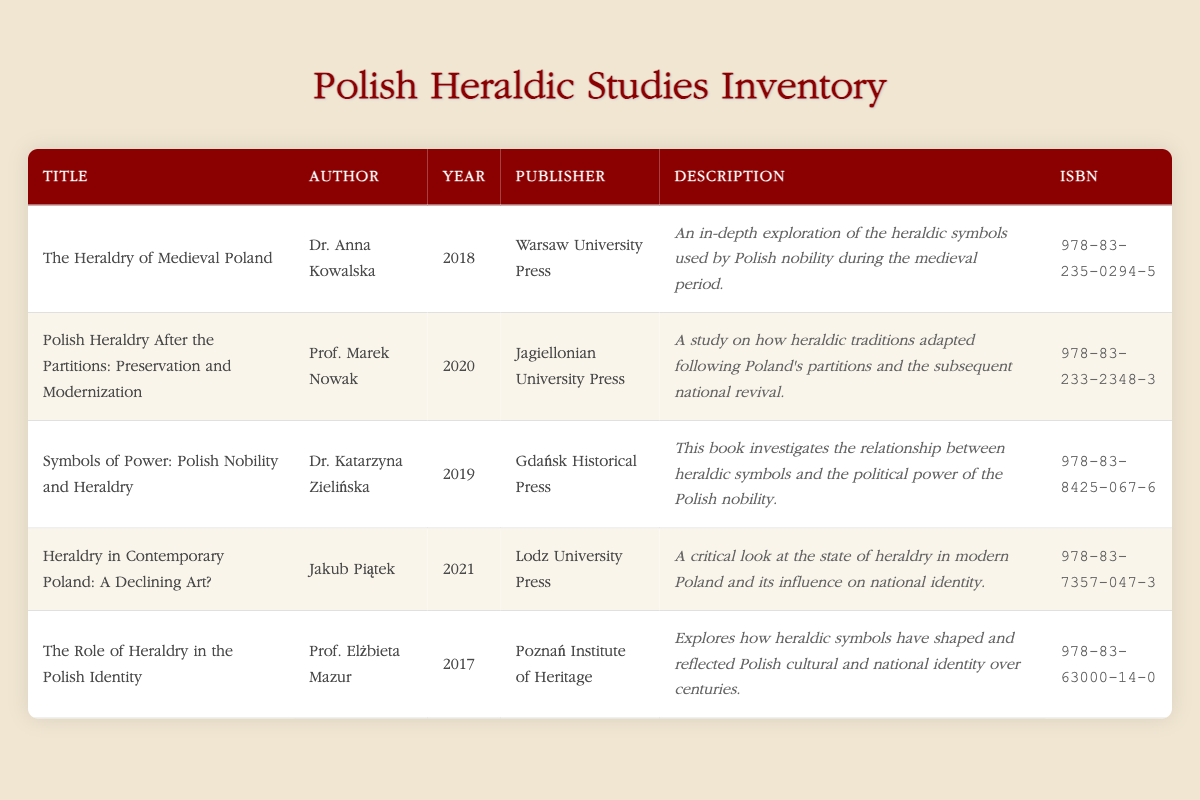What is the title of the book authored by Dr. Anna Kowalska? The table lists the publications and their authors. By scanning through the entries, "The Heraldry of Medieval Poland" corresponds to Dr. Anna Kowalska, who is identified as its author.
Answer: The Heraldry of Medieval Poland How many studies were published after the year 2018? Observing the "Year" column, the publications from 2019, 2020, and 2021 total three: "Symbols of Power: Polish Nobility and Heraldry," "Polish Heraldry After the Partitions: Preservation and Modernization," and "Heraldry in Contemporary Poland: A Declining Art?"
Answer: 3 Which publication focuses on the preservation of heraldic traditions after the partitions? The description of the publication written by Prof. Marek Nowak, titled "Polish Heraldry After the Partitions: Preservation and Modernization," directly indicates that it addresses the preservation of heraldic traditions after Poland's partitions.
Answer: Polish Heraldry After the Partitions: Preservation and Modernization Is "The Role of Heraldry in the Polish Identity" published by a professor? The table provides the author's title next to the name. In this case, Prof. Elżbieta Mazur is identified as the author, confirming that it is indeed published by a professor.
Answer: Yes What is the average publication year of the studies listed in the table? The years of publication are 2017, 2018, 2019, 2020, and 2021. Adding them gives a total of 100. Dividing by the number of studies (5) results in an average year of 20.
Answer: 2019 What is the ISBN of the book published in 2021? By locating the entry for 2021 titled "Heraldry in Contemporary Poland: A Declining Art?" and identifying the corresponding ISBN, it is found to be 978-83-7357-047-3.
Answer: 978-83-7357-047-3 Which author has written about the relationship between heraldic symbols and political power? Reviewing the description of Dr. Katarzyna Zielińska's book titled "Symbols of Power: Polish Nobility and Heraldry" reveals that this study specifically investigates the correlation between heraldic symbols and the political power of the Polish nobility.
Answer: Dr. Katarzyna Zielińska Was there a study published regarding heraldry in contemporary Poland before 2020? Analyzing the publication years, "The Role of Heraldry in the Polish Identity" was published in 2017, and "The Heraldry of Medieval Poland" in 2018, confirming there were studies addressing this theme prior to 2020.
Answer: Yes 